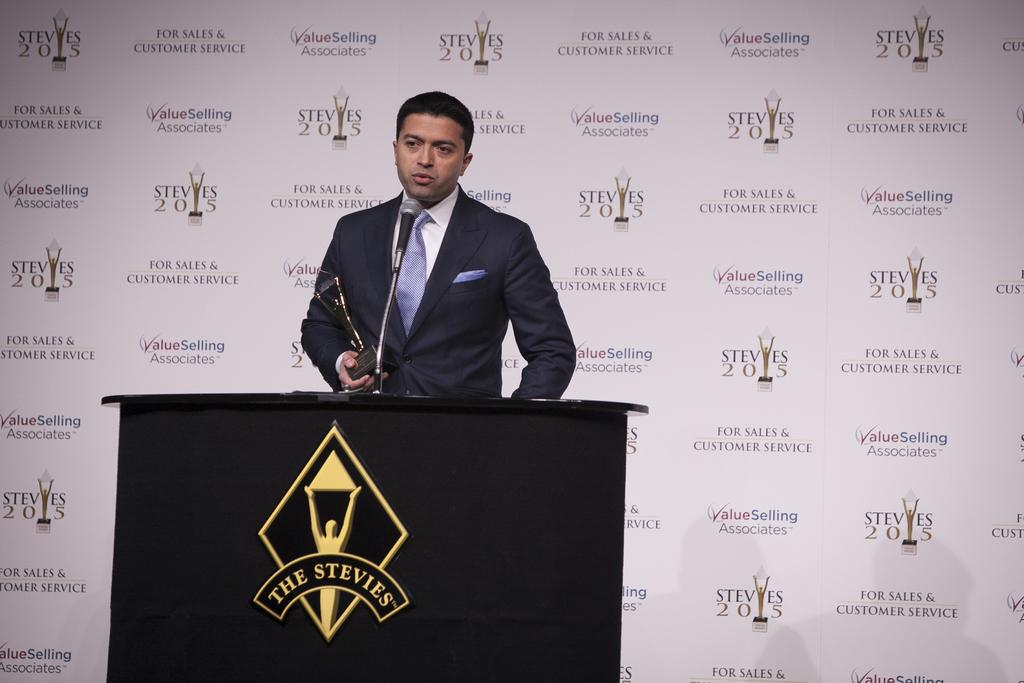Who is the main subject in the foreground of the image? There is a man in the foreground of the image. What is the man holding in the image? The man is holding an award. What is the man standing in front of in the image? The man is standing in front of a podium. What is on the podium in the image? There is a microphone on the podium. What can be seen in the background of the image? There is a banner wall in the background of the image. How many legs does the tin have in the image? There is no tin present in the image, so it is not possible to determine the number of legs it might have. 